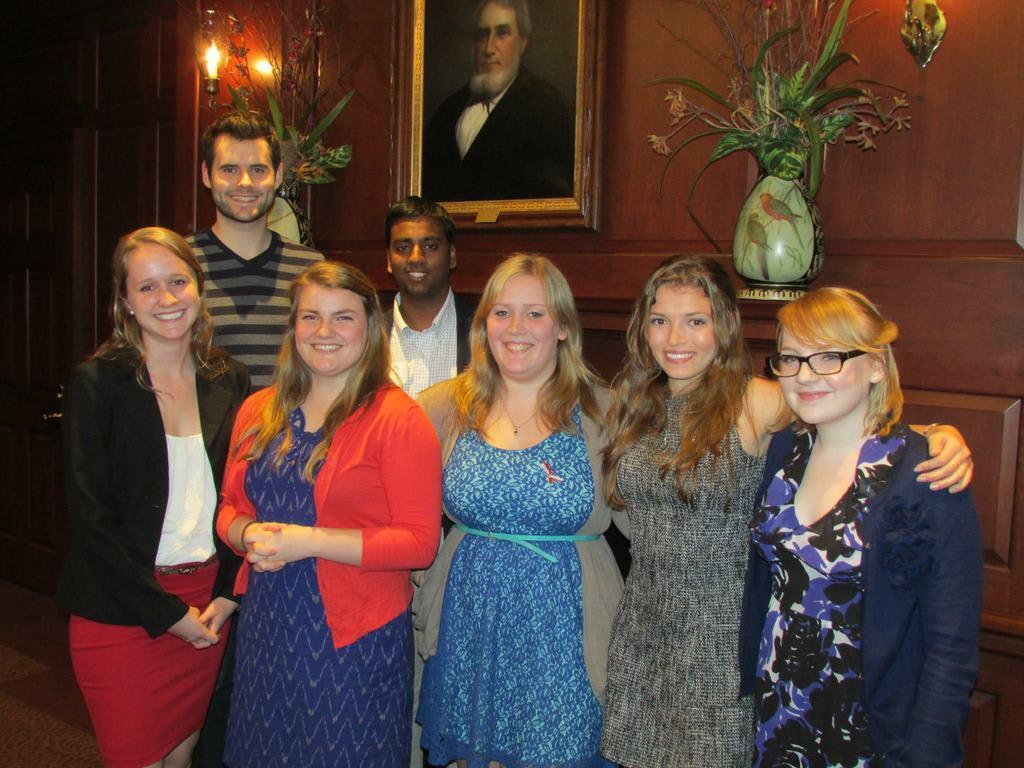How would you summarize this image in a sentence or two? This is the picture of a room. In this image there are group of people standing and smiling. At the back there is a frame on the wall and there is a picture of a person on the frame and there are flower vases and there is a light on the wall. On the left side of the image there is a door. 